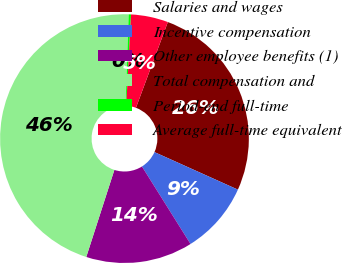Convert chart to OTSL. <chart><loc_0><loc_0><loc_500><loc_500><pie_chart><fcel>Salaries and wages<fcel>Incentive compensation<fcel>Other employee benefits (1)<fcel>Total compensation and<fcel>Period-end full-time<fcel>Average full-time equivalent<nl><fcel>26.06%<fcel>9.36%<fcel>13.88%<fcel>45.57%<fcel>0.3%<fcel>4.83%<nl></chart> 